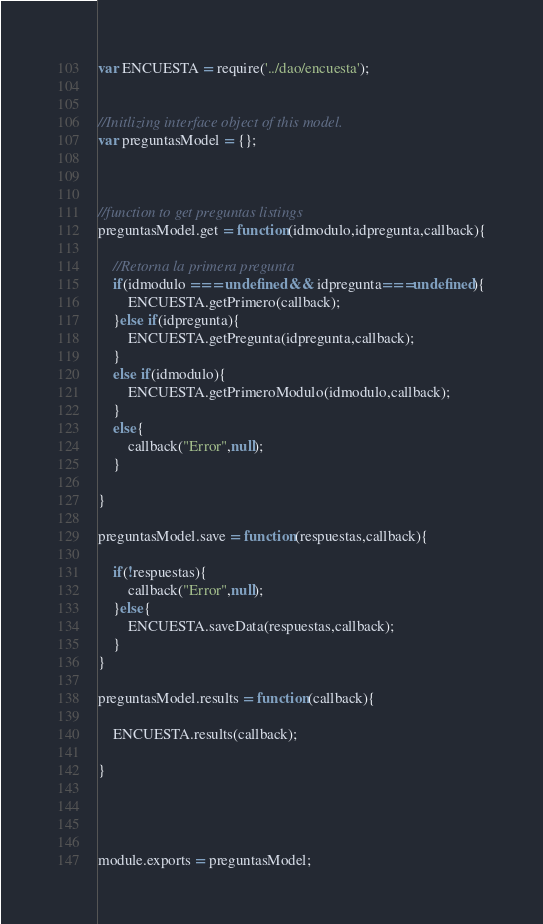Convert code to text. <code><loc_0><loc_0><loc_500><loc_500><_JavaScript_>var ENCUESTA = require('../dao/encuesta');
 

//Initlizing interface object of this model.
var preguntasModel = {};



//function to get preguntas listings
preguntasModel.get = function(idmodulo,idpregunta,callback){
	
	//Retorna la primera pregunta
	if(idmodulo === undefined && idpregunta===undefined){
		ENCUESTA.getPrimero(callback);
	}else if(idpregunta){
		ENCUESTA.getPregunta(idpregunta,callback);		
	}
	else if(idmodulo){
		ENCUESTA.getPrimeroModulo(idmodulo,callback);		
	}
	else{
		callback("Error",null);
	}
	
}

preguntasModel.save = function(respuestas,callback){

	if(!respuestas){
		callback("Error",null);
	}else{
		ENCUESTA.saveData(respuestas,callback);
	}
}

preguntasModel.results = function(callback){

	ENCUESTA.results(callback);

}




module.exports = preguntasModel;</code> 